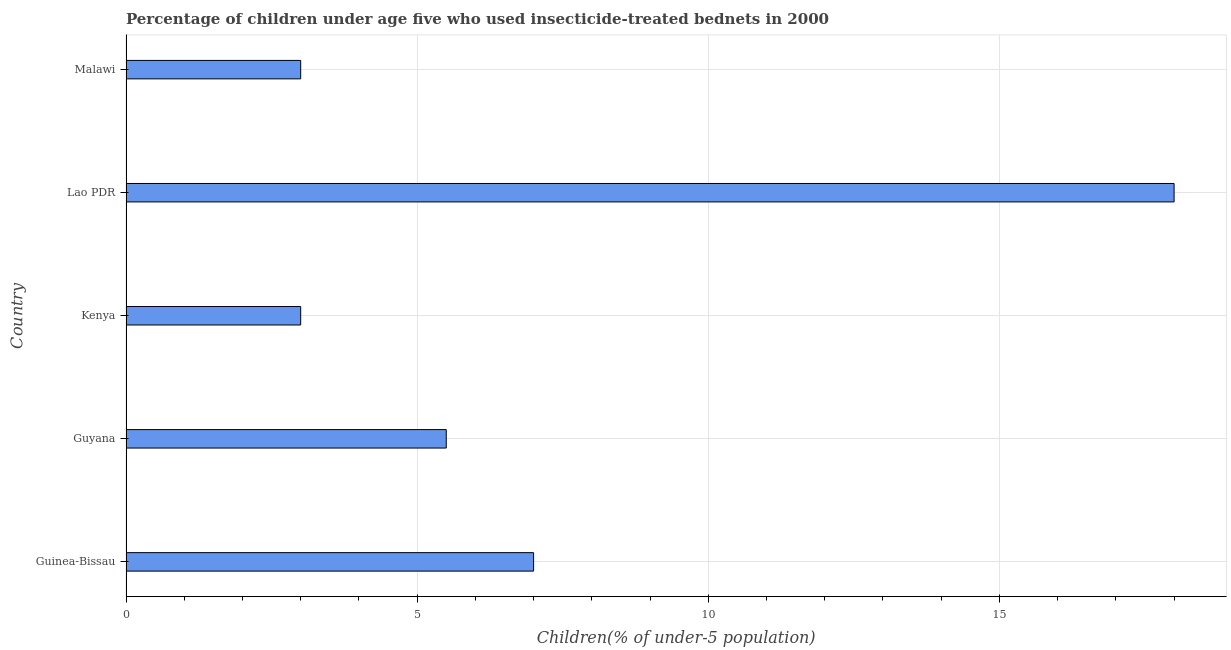Does the graph contain grids?
Your response must be concise. Yes. What is the title of the graph?
Make the answer very short. Percentage of children under age five who used insecticide-treated bednets in 2000. What is the label or title of the X-axis?
Your response must be concise. Children(% of under-5 population). What is the percentage of children who use of insecticide-treated bed nets in Guinea-Bissau?
Keep it short and to the point. 7. Across all countries, what is the minimum percentage of children who use of insecticide-treated bed nets?
Give a very brief answer. 3. In which country was the percentage of children who use of insecticide-treated bed nets maximum?
Offer a terse response. Lao PDR. In which country was the percentage of children who use of insecticide-treated bed nets minimum?
Your response must be concise. Kenya. What is the sum of the percentage of children who use of insecticide-treated bed nets?
Provide a succinct answer. 36.5. What is the average percentage of children who use of insecticide-treated bed nets per country?
Provide a succinct answer. 7.3. In how many countries, is the percentage of children who use of insecticide-treated bed nets greater than 16 %?
Ensure brevity in your answer.  1. What is the ratio of the percentage of children who use of insecticide-treated bed nets in Lao PDR to that in Malawi?
Your answer should be compact. 6. Is the difference between the percentage of children who use of insecticide-treated bed nets in Kenya and Malawi greater than the difference between any two countries?
Your answer should be very brief. No. Is the sum of the percentage of children who use of insecticide-treated bed nets in Kenya and Lao PDR greater than the maximum percentage of children who use of insecticide-treated bed nets across all countries?
Make the answer very short. Yes. What is the difference between the highest and the lowest percentage of children who use of insecticide-treated bed nets?
Your answer should be compact. 15. How many bars are there?
Your answer should be very brief. 5. Are the values on the major ticks of X-axis written in scientific E-notation?
Offer a terse response. No. What is the Children(% of under-5 population) in Guinea-Bissau?
Make the answer very short. 7. What is the Children(% of under-5 population) in Kenya?
Your answer should be compact. 3. What is the Children(% of under-5 population) in Malawi?
Offer a very short reply. 3. What is the difference between the Children(% of under-5 population) in Guinea-Bissau and Guyana?
Ensure brevity in your answer.  1.5. What is the difference between the Children(% of under-5 population) in Guinea-Bissau and Kenya?
Give a very brief answer. 4. What is the difference between the Children(% of under-5 population) in Guinea-Bissau and Lao PDR?
Give a very brief answer. -11. What is the difference between the Children(% of under-5 population) in Guinea-Bissau and Malawi?
Give a very brief answer. 4. What is the difference between the Children(% of under-5 population) in Guyana and Kenya?
Your answer should be compact. 2.5. What is the difference between the Children(% of under-5 population) in Guyana and Malawi?
Provide a short and direct response. 2.5. What is the difference between the Children(% of under-5 population) in Kenya and Lao PDR?
Provide a short and direct response. -15. What is the difference between the Children(% of under-5 population) in Kenya and Malawi?
Provide a short and direct response. 0. What is the difference between the Children(% of under-5 population) in Lao PDR and Malawi?
Make the answer very short. 15. What is the ratio of the Children(% of under-5 population) in Guinea-Bissau to that in Guyana?
Provide a succinct answer. 1.27. What is the ratio of the Children(% of under-5 population) in Guinea-Bissau to that in Kenya?
Provide a succinct answer. 2.33. What is the ratio of the Children(% of under-5 population) in Guinea-Bissau to that in Lao PDR?
Give a very brief answer. 0.39. What is the ratio of the Children(% of under-5 population) in Guinea-Bissau to that in Malawi?
Offer a terse response. 2.33. What is the ratio of the Children(% of under-5 population) in Guyana to that in Kenya?
Offer a terse response. 1.83. What is the ratio of the Children(% of under-5 population) in Guyana to that in Lao PDR?
Offer a terse response. 0.31. What is the ratio of the Children(% of under-5 population) in Guyana to that in Malawi?
Offer a terse response. 1.83. What is the ratio of the Children(% of under-5 population) in Kenya to that in Lao PDR?
Keep it short and to the point. 0.17. 